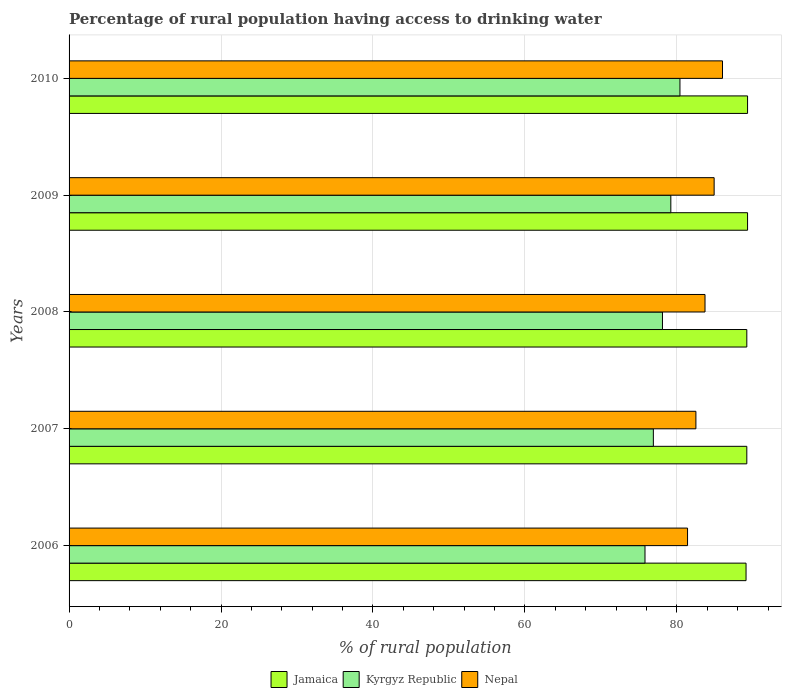How many different coloured bars are there?
Your response must be concise. 3. Are the number of bars per tick equal to the number of legend labels?
Provide a short and direct response. Yes. Are the number of bars on each tick of the Y-axis equal?
Ensure brevity in your answer.  Yes. In how many cases, is the number of bars for a given year not equal to the number of legend labels?
Offer a terse response. 0. What is the percentage of rural population having access to drinking water in Nepal in 2009?
Offer a terse response. 84.9. Across all years, what is the maximum percentage of rural population having access to drinking water in Kyrgyz Republic?
Provide a succinct answer. 80.4. Across all years, what is the minimum percentage of rural population having access to drinking water in Nepal?
Ensure brevity in your answer.  81.4. What is the total percentage of rural population having access to drinking water in Jamaica in the graph?
Your response must be concise. 446.1. What is the difference between the percentage of rural population having access to drinking water in Nepal in 2006 and that in 2009?
Ensure brevity in your answer.  -3.5. What is the difference between the percentage of rural population having access to drinking water in Jamaica in 2008 and the percentage of rural population having access to drinking water in Nepal in 2007?
Provide a succinct answer. 6.7. What is the average percentage of rural population having access to drinking water in Jamaica per year?
Offer a very short reply. 89.22. In the year 2006, what is the difference between the percentage of rural population having access to drinking water in Jamaica and percentage of rural population having access to drinking water in Kyrgyz Republic?
Keep it short and to the point. 13.3. In how many years, is the percentage of rural population having access to drinking water in Kyrgyz Republic greater than 20 %?
Offer a very short reply. 5. What is the ratio of the percentage of rural population having access to drinking water in Jamaica in 2007 to that in 2010?
Keep it short and to the point. 1. Is the difference between the percentage of rural population having access to drinking water in Jamaica in 2006 and 2009 greater than the difference between the percentage of rural population having access to drinking water in Kyrgyz Republic in 2006 and 2009?
Make the answer very short. Yes. What is the difference between the highest and the second highest percentage of rural population having access to drinking water in Kyrgyz Republic?
Your answer should be very brief. 1.2. What is the difference between the highest and the lowest percentage of rural population having access to drinking water in Nepal?
Your answer should be very brief. 4.6. Is the sum of the percentage of rural population having access to drinking water in Kyrgyz Republic in 2008 and 2010 greater than the maximum percentage of rural population having access to drinking water in Nepal across all years?
Ensure brevity in your answer.  Yes. What does the 3rd bar from the top in 2009 represents?
Ensure brevity in your answer.  Jamaica. What does the 3rd bar from the bottom in 2009 represents?
Your response must be concise. Nepal. Are all the bars in the graph horizontal?
Keep it short and to the point. Yes. How many years are there in the graph?
Provide a succinct answer. 5. What is the difference between two consecutive major ticks on the X-axis?
Offer a very short reply. 20. Are the values on the major ticks of X-axis written in scientific E-notation?
Your answer should be very brief. No. Does the graph contain grids?
Provide a succinct answer. Yes. Where does the legend appear in the graph?
Your response must be concise. Bottom center. How are the legend labels stacked?
Provide a succinct answer. Horizontal. What is the title of the graph?
Offer a very short reply. Percentage of rural population having access to drinking water. What is the label or title of the X-axis?
Your response must be concise. % of rural population. What is the label or title of the Y-axis?
Keep it short and to the point. Years. What is the % of rural population of Jamaica in 2006?
Your answer should be compact. 89.1. What is the % of rural population in Kyrgyz Republic in 2006?
Provide a short and direct response. 75.8. What is the % of rural population of Nepal in 2006?
Ensure brevity in your answer.  81.4. What is the % of rural population of Jamaica in 2007?
Your answer should be very brief. 89.2. What is the % of rural population of Kyrgyz Republic in 2007?
Your response must be concise. 76.9. What is the % of rural population in Nepal in 2007?
Your answer should be very brief. 82.5. What is the % of rural population of Jamaica in 2008?
Offer a terse response. 89.2. What is the % of rural population of Kyrgyz Republic in 2008?
Keep it short and to the point. 78.1. What is the % of rural population of Nepal in 2008?
Offer a terse response. 83.7. What is the % of rural population of Jamaica in 2009?
Make the answer very short. 89.3. What is the % of rural population of Kyrgyz Republic in 2009?
Your answer should be compact. 79.2. What is the % of rural population in Nepal in 2009?
Your answer should be very brief. 84.9. What is the % of rural population in Jamaica in 2010?
Give a very brief answer. 89.3. What is the % of rural population in Kyrgyz Republic in 2010?
Keep it short and to the point. 80.4. Across all years, what is the maximum % of rural population in Jamaica?
Offer a very short reply. 89.3. Across all years, what is the maximum % of rural population in Kyrgyz Republic?
Offer a terse response. 80.4. Across all years, what is the maximum % of rural population of Nepal?
Your answer should be compact. 86. Across all years, what is the minimum % of rural population of Jamaica?
Provide a short and direct response. 89.1. Across all years, what is the minimum % of rural population of Kyrgyz Republic?
Offer a very short reply. 75.8. Across all years, what is the minimum % of rural population of Nepal?
Provide a short and direct response. 81.4. What is the total % of rural population of Jamaica in the graph?
Your response must be concise. 446.1. What is the total % of rural population in Kyrgyz Republic in the graph?
Ensure brevity in your answer.  390.4. What is the total % of rural population in Nepal in the graph?
Offer a terse response. 418.5. What is the difference between the % of rural population of Jamaica in 2006 and that in 2007?
Your answer should be very brief. -0.1. What is the difference between the % of rural population of Kyrgyz Republic in 2006 and that in 2007?
Your response must be concise. -1.1. What is the difference between the % of rural population in Nepal in 2006 and that in 2008?
Keep it short and to the point. -2.3. What is the difference between the % of rural population in Jamaica in 2006 and that in 2009?
Make the answer very short. -0.2. What is the difference between the % of rural population in Jamaica in 2006 and that in 2010?
Provide a succinct answer. -0.2. What is the difference between the % of rural population of Kyrgyz Republic in 2006 and that in 2010?
Offer a terse response. -4.6. What is the difference between the % of rural population in Nepal in 2006 and that in 2010?
Provide a succinct answer. -4.6. What is the difference between the % of rural population in Kyrgyz Republic in 2007 and that in 2008?
Ensure brevity in your answer.  -1.2. What is the difference between the % of rural population in Nepal in 2007 and that in 2008?
Your answer should be very brief. -1.2. What is the difference between the % of rural population in Nepal in 2007 and that in 2009?
Offer a terse response. -2.4. What is the difference between the % of rural population in Nepal in 2008 and that in 2010?
Provide a succinct answer. -2.3. What is the difference between the % of rural population in Jamaica in 2009 and that in 2010?
Give a very brief answer. 0. What is the difference between the % of rural population in Nepal in 2009 and that in 2010?
Offer a terse response. -1.1. What is the difference between the % of rural population in Jamaica in 2006 and the % of rural population in Kyrgyz Republic in 2008?
Your answer should be very brief. 11. What is the difference between the % of rural population in Jamaica in 2006 and the % of rural population in Nepal in 2008?
Your answer should be very brief. 5.4. What is the difference between the % of rural population in Kyrgyz Republic in 2006 and the % of rural population in Nepal in 2008?
Provide a short and direct response. -7.9. What is the difference between the % of rural population of Jamaica in 2006 and the % of rural population of Kyrgyz Republic in 2009?
Provide a succinct answer. 9.9. What is the difference between the % of rural population of Jamaica in 2006 and the % of rural population of Nepal in 2009?
Your response must be concise. 4.2. What is the difference between the % of rural population of Jamaica in 2006 and the % of rural population of Kyrgyz Republic in 2010?
Your answer should be compact. 8.7. What is the difference between the % of rural population of Kyrgyz Republic in 2007 and the % of rural population of Nepal in 2008?
Make the answer very short. -6.8. What is the difference between the % of rural population in Jamaica in 2007 and the % of rural population in Kyrgyz Republic in 2010?
Provide a succinct answer. 8.8. What is the difference between the % of rural population in Jamaica in 2007 and the % of rural population in Nepal in 2010?
Offer a terse response. 3.2. What is the difference between the % of rural population of Jamaica in 2008 and the % of rural population of Nepal in 2010?
Your response must be concise. 3.2. What is the difference between the % of rural population in Jamaica in 2009 and the % of rural population in Kyrgyz Republic in 2010?
Your answer should be compact. 8.9. What is the difference between the % of rural population in Jamaica in 2009 and the % of rural population in Nepal in 2010?
Keep it short and to the point. 3.3. What is the difference between the % of rural population of Kyrgyz Republic in 2009 and the % of rural population of Nepal in 2010?
Ensure brevity in your answer.  -6.8. What is the average % of rural population of Jamaica per year?
Ensure brevity in your answer.  89.22. What is the average % of rural population in Kyrgyz Republic per year?
Provide a succinct answer. 78.08. What is the average % of rural population in Nepal per year?
Provide a succinct answer. 83.7. In the year 2006, what is the difference between the % of rural population in Kyrgyz Republic and % of rural population in Nepal?
Provide a short and direct response. -5.6. In the year 2007, what is the difference between the % of rural population in Jamaica and % of rural population in Kyrgyz Republic?
Provide a succinct answer. 12.3. In the year 2007, what is the difference between the % of rural population in Jamaica and % of rural population in Nepal?
Your answer should be very brief. 6.7. In the year 2007, what is the difference between the % of rural population in Kyrgyz Republic and % of rural population in Nepal?
Make the answer very short. -5.6. In the year 2008, what is the difference between the % of rural population in Jamaica and % of rural population in Kyrgyz Republic?
Ensure brevity in your answer.  11.1. In the year 2008, what is the difference between the % of rural population of Kyrgyz Republic and % of rural population of Nepal?
Your answer should be very brief. -5.6. In the year 2009, what is the difference between the % of rural population in Jamaica and % of rural population in Kyrgyz Republic?
Offer a terse response. 10.1. In the year 2010, what is the difference between the % of rural population in Jamaica and % of rural population in Kyrgyz Republic?
Your answer should be compact. 8.9. What is the ratio of the % of rural population in Kyrgyz Republic in 2006 to that in 2007?
Ensure brevity in your answer.  0.99. What is the ratio of the % of rural population of Nepal in 2006 to that in 2007?
Provide a short and direct response. 0.99. What is the ratio of the % of rural population in Kyrgyz Republic in 2006 to that in 2008?
Your answer should be compact. 0.97. What is the ratio of the % of rural population in Nepal in 2006 to that in 2008?
Provide a succinct answer. 0.97. What is the ratio of the % of rural population in Kyrgyz Republic in 2006 to that in 2009?
Ensure brevity in your answer.  0.96. What is the ratio of the % of rural population in Nepal in 2006 to that in 2009?
Keep it short and to the point. 0.96. What is the ratio of the % of rural population in Kyrgyz Republic in 2006 to that in 2010?
Offer a terse response. 0.94. What is the ratio of the % of rural population in Nepal in 2006 to that in 2010?
Offer a very short reply. 0.95. What is the ratio of the % of rural population of Kyrgyz Republic in 2007 to that in 2008?
Keep it short and to the point. 0.98. What is the ratio of the % of rural population of Nepal in 2007 to that in 2008?
Give a very brief answer. 0.99. What is the ratio of the % of rural population in Jamaica in 2007 to that in 2009?
Your answer should be compact. 1. What is the ratio of the % of rural population of Nepal in 2007 to that in 2009?
Give a very brief answer. 0.97. What is the ratio of the % of rural population of Kyrgyz Republic in 2007 to that in 2010?
Your response must be concise. 0.96. What is the ratio of the % of rural population of Nepal in 2007 to that in 2010?
Give a very brief answer. 0.96. What is the ratio of the % of rural population in Kyrgyz Republic in 2008 to that in 2009?
Provide a short and direct response. 0.99. What is the ratio of the % of rural population of Nepal in 2008 to that in 2009?
Offer a very short reply. 0.99. What is the ratio of the % of rural population in Kyrgyz Republic in 2008 to that in 2010?
Your answer should be very brief. 0.97. What is the ratio of the % of rural population in Nepal in 2008 to that in 2010?
Ensure brevity in your answer.  0.97. What is the ratio of the % of rural population in Kyrgyz Republic in 2009 to that in 2010?
Give a very brief answer. 0.99. What is the ratio of the % of rural population of Nepal in 2009 to that in 2010?
Keep it short and to the point. 0.99. What is the difference between the highest and the second highest % of rural population in Jamaica?
Your response must be concise. 0. What is the difference between the highest and the second highest % of rural population in Kyrgyz Republic?
Ensure brevity in your answer.  1.2. What is the difference between the highest and the second highest % of rural population in Nepal?
Offer a terse response. 1.1. What is the difference between the highest and the lowest % of rural population in Jamaica?
Your response must be concise. 0.2. 